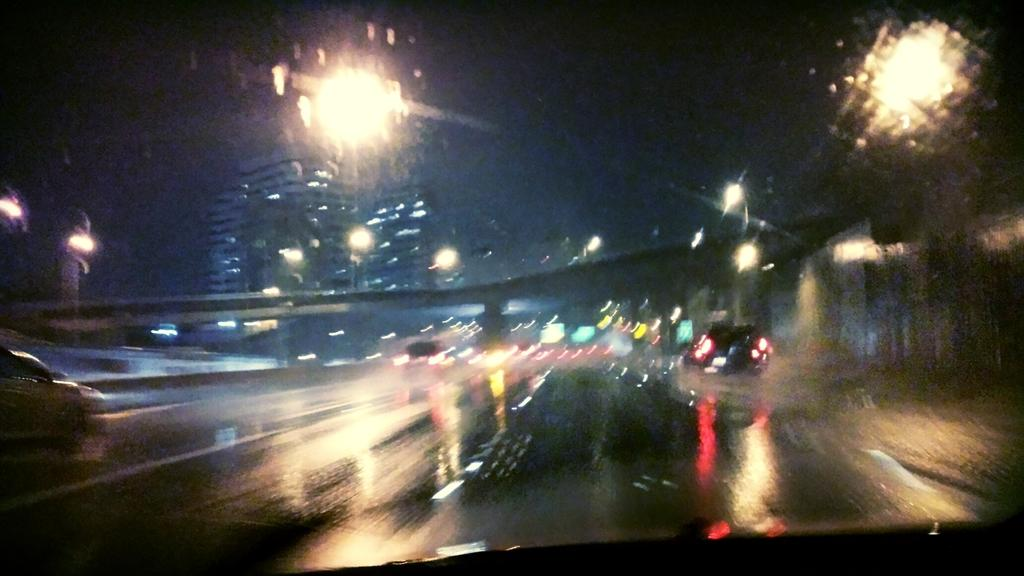What can be seen on the road in the image? There are vehicles on the road in the image. What is visible in the background of the image? There is a bridge and buildings in the background of the image. What type of illumination is present in the image? There are lights visible in the image. What is the color of the sky in the image? The sky appears to be black in color. Can you see a nest in the image? There is no nest present in the image. Is there an actor visible in the image? There is no actor present in the image. 